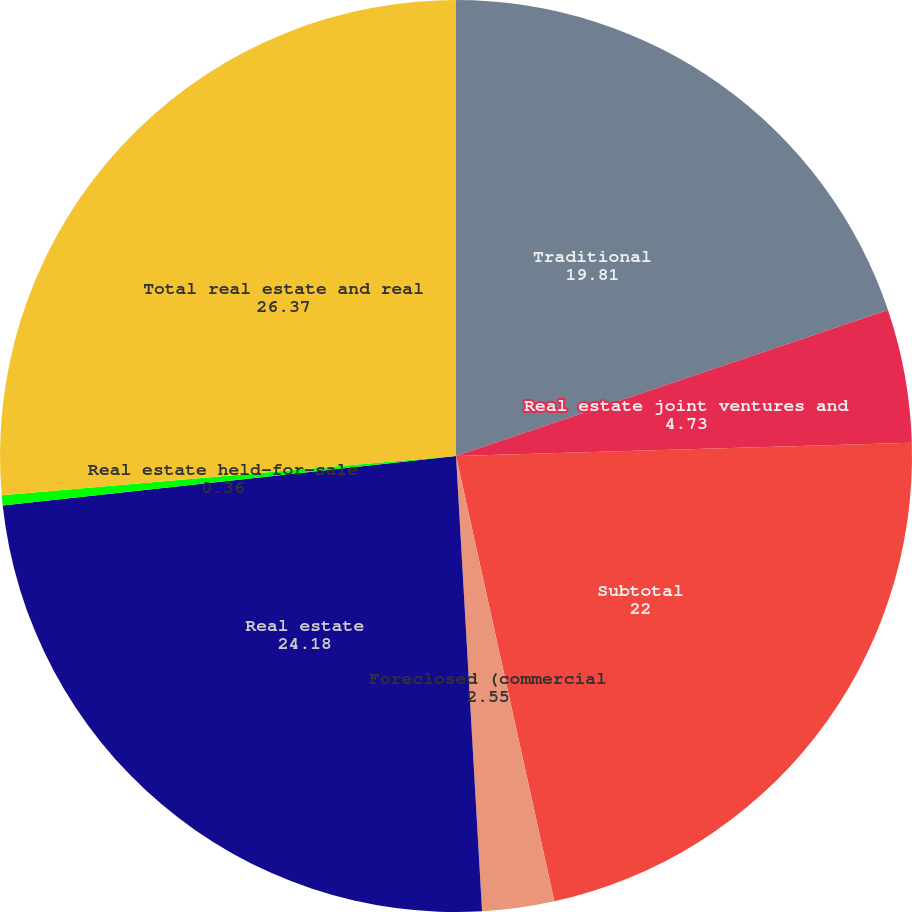<chart> <loc_0><loc_0><loc_500><loc_500><pie_chart><fcel>Traditional<fcel>Real estate joint ventures and<fcel>Subtotal<fcel>Foreclosed (commercial<fcel>Real estate<fcel>Real estate held-for-sale<fcel>Total real estate and real<nl><fcel>19.81%<fcel>4.73%<fcel>22.0%<fcel>2.55%<fcel>24.18%<fcel>0.36%<fcel>26.37%<nl></chart> 